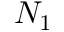Convert formula to latex. <formula><loc_0><loc_0><loc_500><loc_500>N _ { 1 }</formula> 